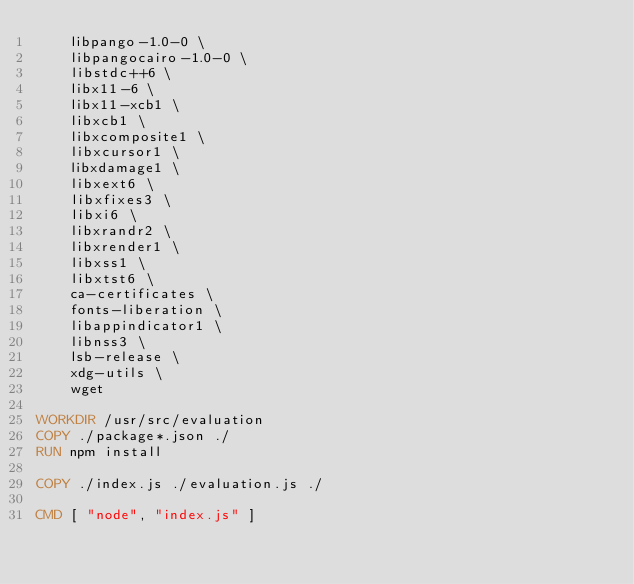<code> <loc_0><loc_0><loc_500><loc_500><_Dockerfile_>    libpango-1.0-0 \
    libpangocairo-1.0-0 \
    libstdc++6 \
    libx11-6 \
    libx11-xcb1 \
    libxcb1 \
    libxcomposite1 \
    libxcursor1 \
    libxdamage1 \
    libxext6 \
    libxfixes3 \
    libxi6 \
    libxrandr2 \
    libxrender1 \
    libxss1 \
    libxtst6 \
    ca-certificates \
    fonts-liberation \
    libappindicator1 \
    libnss3 \
    lsb-release \
    xdg-utils \
    wget

WORKDIR /usr/src/evaluation
COPY ./package*.json ./
RUN npm install

COPY ./index.js ./evaluation.js ./

CMD [ "node", "index.js" ]
</code> 